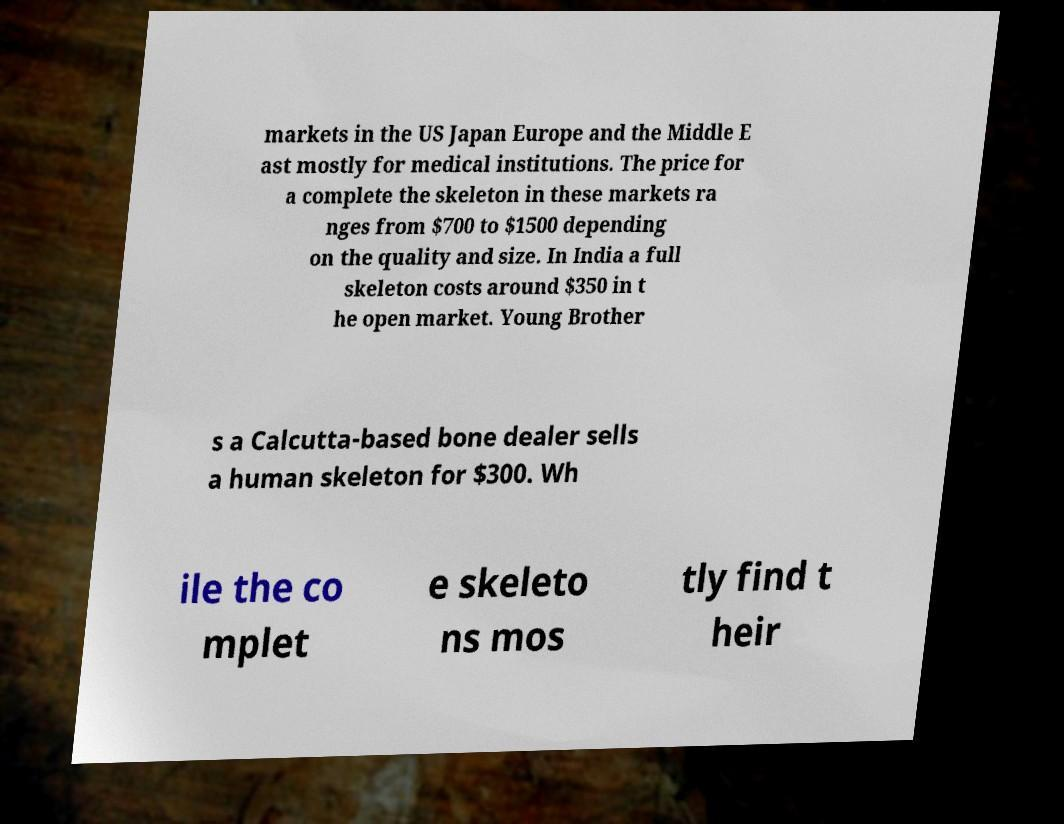There's text embedded in this image that I need extracted. Can you transcribe it verbatim? markets in the US Japan Europe and the Middle E ast mostly for medical institutions. The price for a complete the skeleton in these markets ra nges from $700 to $1500 depending on the quality and size. In India a full skeleton costs around $350 in t he open market. Young Brother s a Calcutta-based bone dealer sells a human skeleton for $300. Wh ile the co mplet e skeleto ns mos tly find t heir 